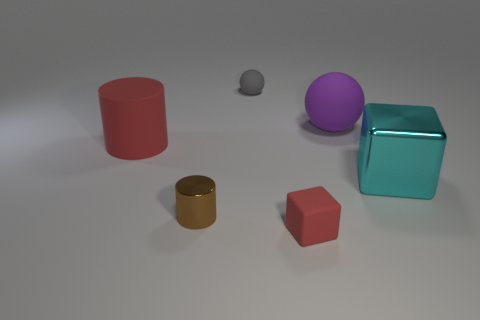What is the size of the matte object that is the same color as the large matte cylinder?
Make the answer very short. Small. There is a big purple rubber thing; is it the same shape as the red rubber thing behind the large cyan block?
Provide a succinct answer. No. What size is the rubber object that is the same shape as the cyan metal thing?
Provide a short and direct response. Small. There is a large sphere; is its color the same as the cube that is behind the red matte block?
Your answer should be very brief. No. The red matte object that is behind the thing right of the large rubber sphere right of the small red matte block is what shape?
Keep it short and to the point. Cylinder. There is a matte cylinder; is its size the same as the red rubber object right of the gray rubber sphere?
Make the answer very short. No. The matte object that is both to the right of the gray rubber ball and on the left side of the large purple rubber ball is what color?
Your answer should be compact. Red. Is the color of the big matte object to the left of the small brown metallic object the same as the metallic thing to the left of the cyan metal cube?
Ensure brevity in your answer.  No. Is the size of the cyan thing behind the tiny red thing the same as the matte block that is in front of the big red rubber object?
Your answer should be very brief. No. Is there any other thing that is the same material as the small brown cylinder?
Your answer should be compact. Yes. 